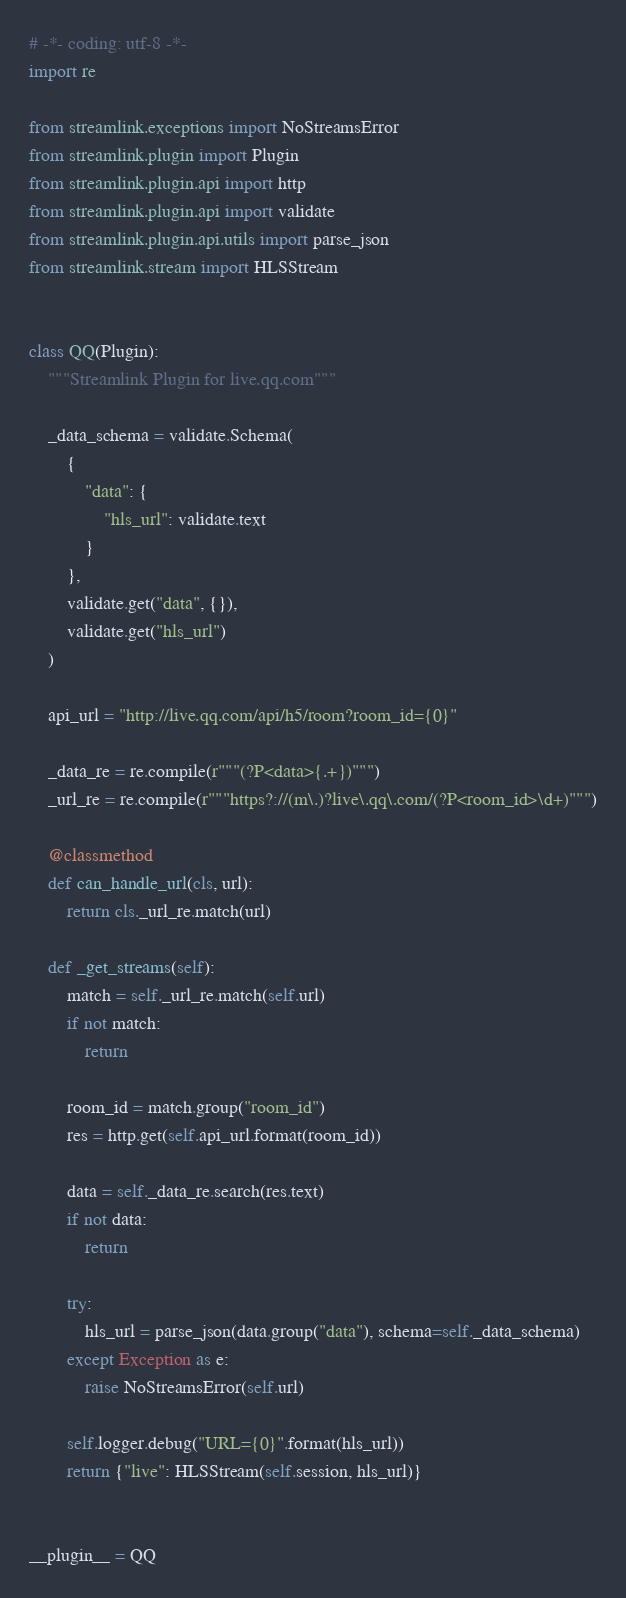<code> <loc_0><loc_0><loc_500><loc_500><_Python_># -*- coding: utf-8 -*-
import re

from streamlink.exceptions import NoStreamsError
from streamlink.plugin import Plugin
from streamlink.plugin.api import http
from streamlink.plugin.api import validate
from streamlink.plugin.api.utils import parse_json
from streamlink.stream import HLSStream


class QQ(Plugin):
    """Streamlink Plugin for live.qq.com"""

    _data_schema = validate.Schema(
        {
            "data": {
                "hls_url": validate.text
            }
        },
        validate.get("data", {}),
        validate.get("hls_url")
    )

    api_url = "http://live.qq.com/api/h5/room?room_id={0}"

    _data_re = re.compile(r"""(?P<data>{.+})""")
    _url_re = re.compile(r"""https?://(m\.)?live\.qq\.com/(?P<room_id>\d+)""")

    @classmethod
    def can_handle_url(cls, url):
        return cls._url_re.match(url)

    def _get_streams(self):
        match = self._url_re.match(self.url)
        if not match:
            return

        room_id = match.group("room_id")
        res = http.get(self.api_url.format(room_id))

        data = self._data_re.search(res.text)
        if not data:
            return

        try:
            hls_url = parse_json(data.group("data"), schema=self._data_schema)
        except Exception as e:
            raise NoStreamsError(self.url)

        self.logger.debug("URL={0}".format(hls_url))
        return {"live": HLSStream(self.session, hls_url)}


__plugin__ = QQ
</code> 